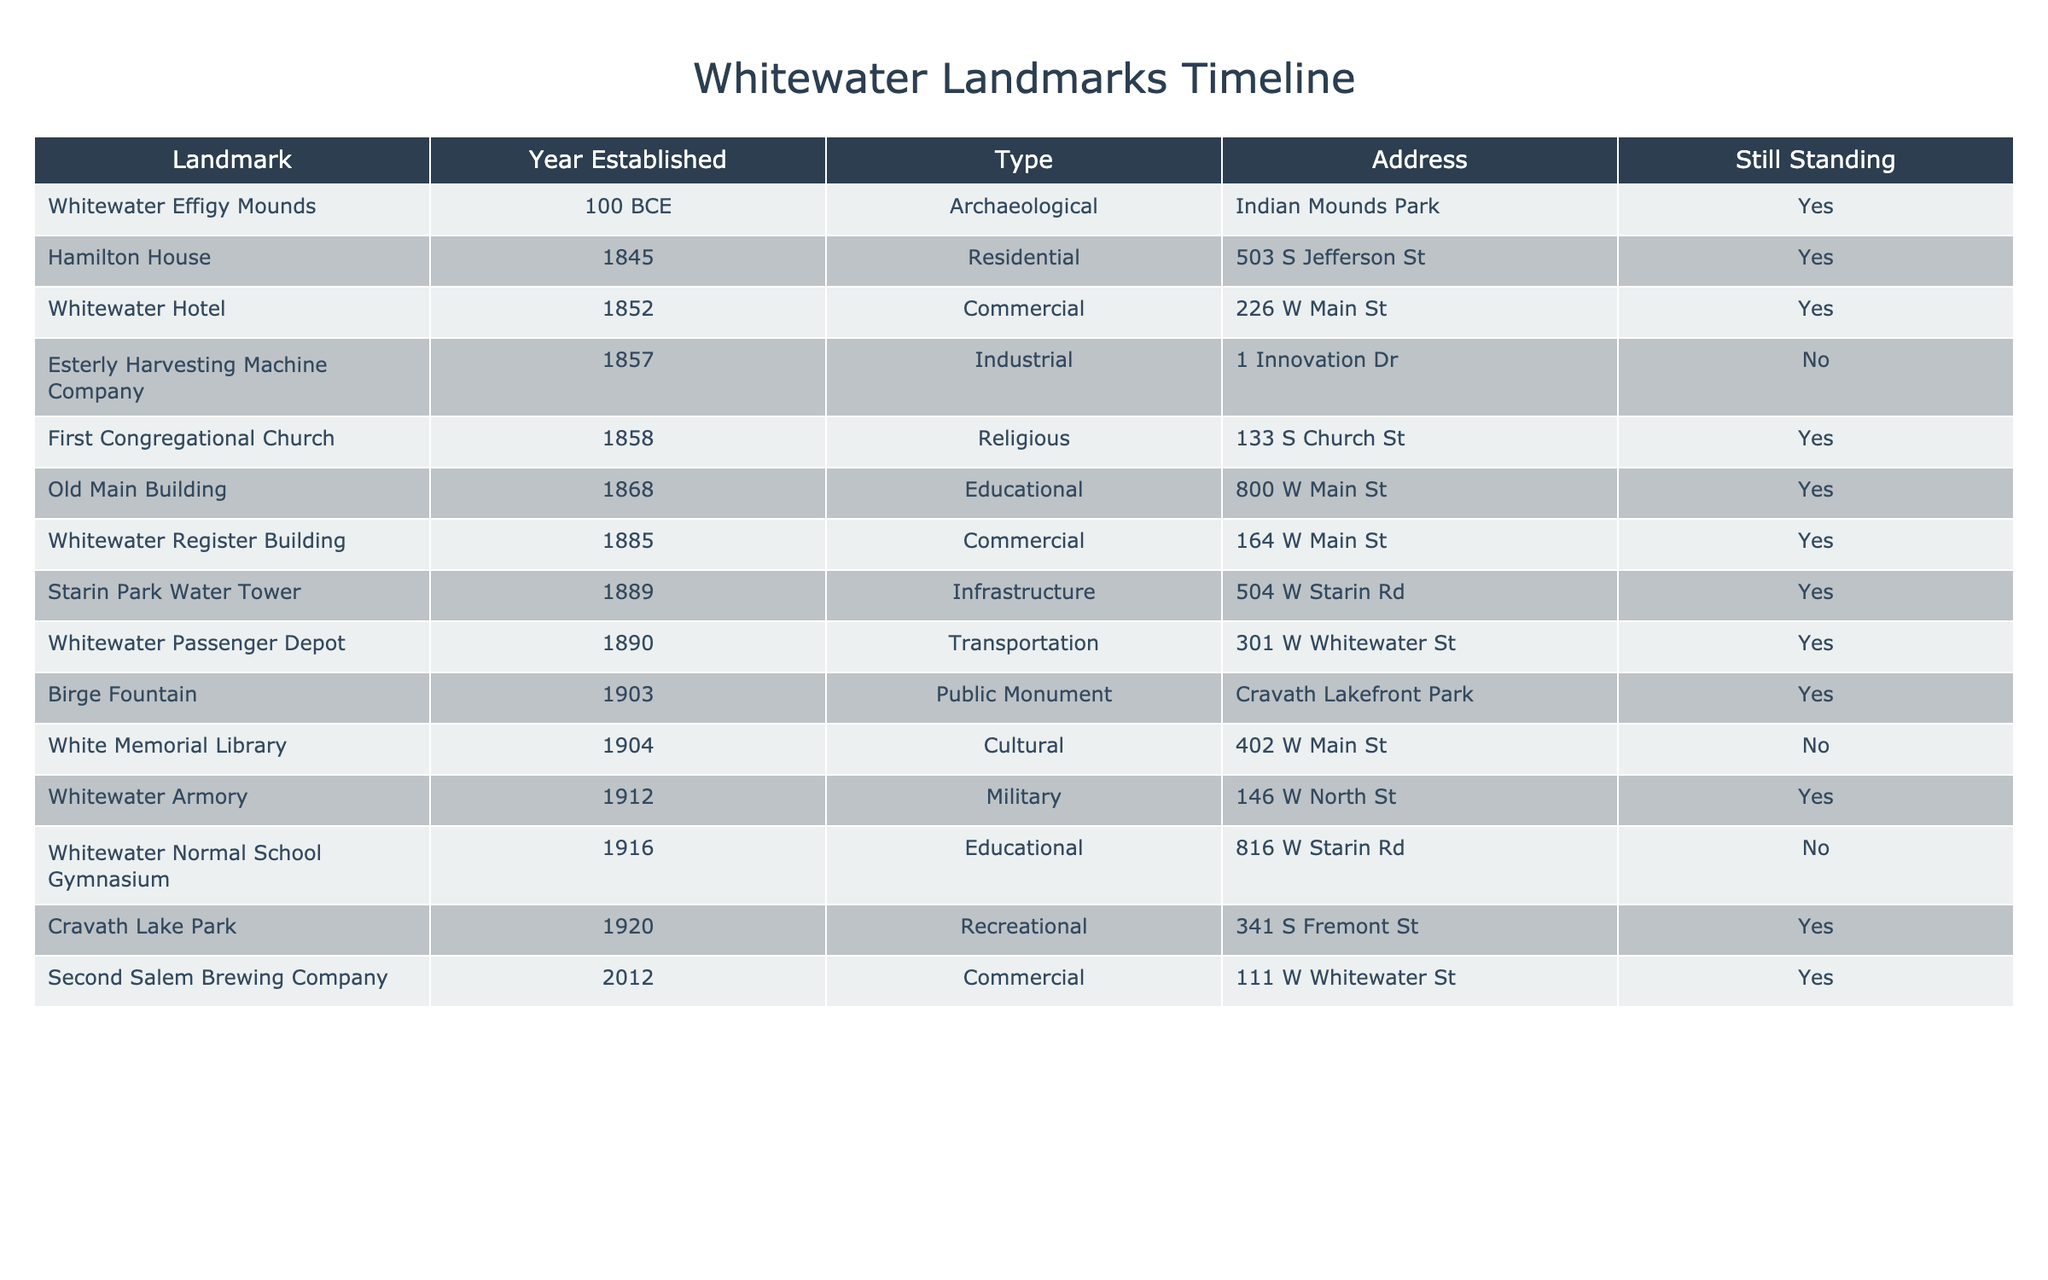What year was the Whitewater Hotel established? By looking at the table, we can directly find the entry for the Whitewater Hotel in the "Year Established" column, which states it was established in 1852.
Answer: 1852 Which landmark was established first? The table lists the landmarks in order of their year of establishment. The Whitewater Effigy Mounds is the earliest, established in 100 BCE.
Answer: 100 BCE How many landmarks are still standing? We can count the "Yes" entries in the "Still Standing" column. There are 11 landmarks listed as still standing.
Answer: 11 What is the most recent landmark established? Finding the latest year in the "Year Established" column, we see that the Second Salem Brewing Company was established in 2012, which is the most recent.
Answer: 2012 Are there any landmarks established in the 19th century that are not still standing? We look at the entries from the 19th century and check their status in the "Still Standing" column. The White Memorial Library and Esterly Harvesting Machine Company are the ones that are not still standing (marked as "No").
Answer: Yes Which landmark has the address "301 W Whitewater St"? By searching the table for the address "301 W Whitewater St," we see it corresponds to the Whitewater Passenger Depot established in 1890.
Answer: Whitewater Passenger Depot How many educational landmarks were established before 1900? We filter the table for educational landmarks and check the "Year Established" column. Old Main Building (1868) and Whitewater Normal School Gymnasium (1916) are the educational landmarks. Only Old Main Building (1868) was established before 1900.
Answer: 1 Which type of landmark has the oldest establishment year? We analyze the establishment years across all types. The Whitewater Effigy Mounds, established in 100 BCE, is the oldest.
Answer: Archaeological Is there a religious landmark that is still standing? We check the entry for the First Congregational Church under the "Religious" type. It is marked as still standing ("Yes").
Answer: Yes Which infrastructure landmark was established in 1889? Looking at the "Year Established" column, we see that the Starin Park Water Tower is listed as established in 1889 under the "Infrastructure" type.
Answer: Starin Park Water Tower 